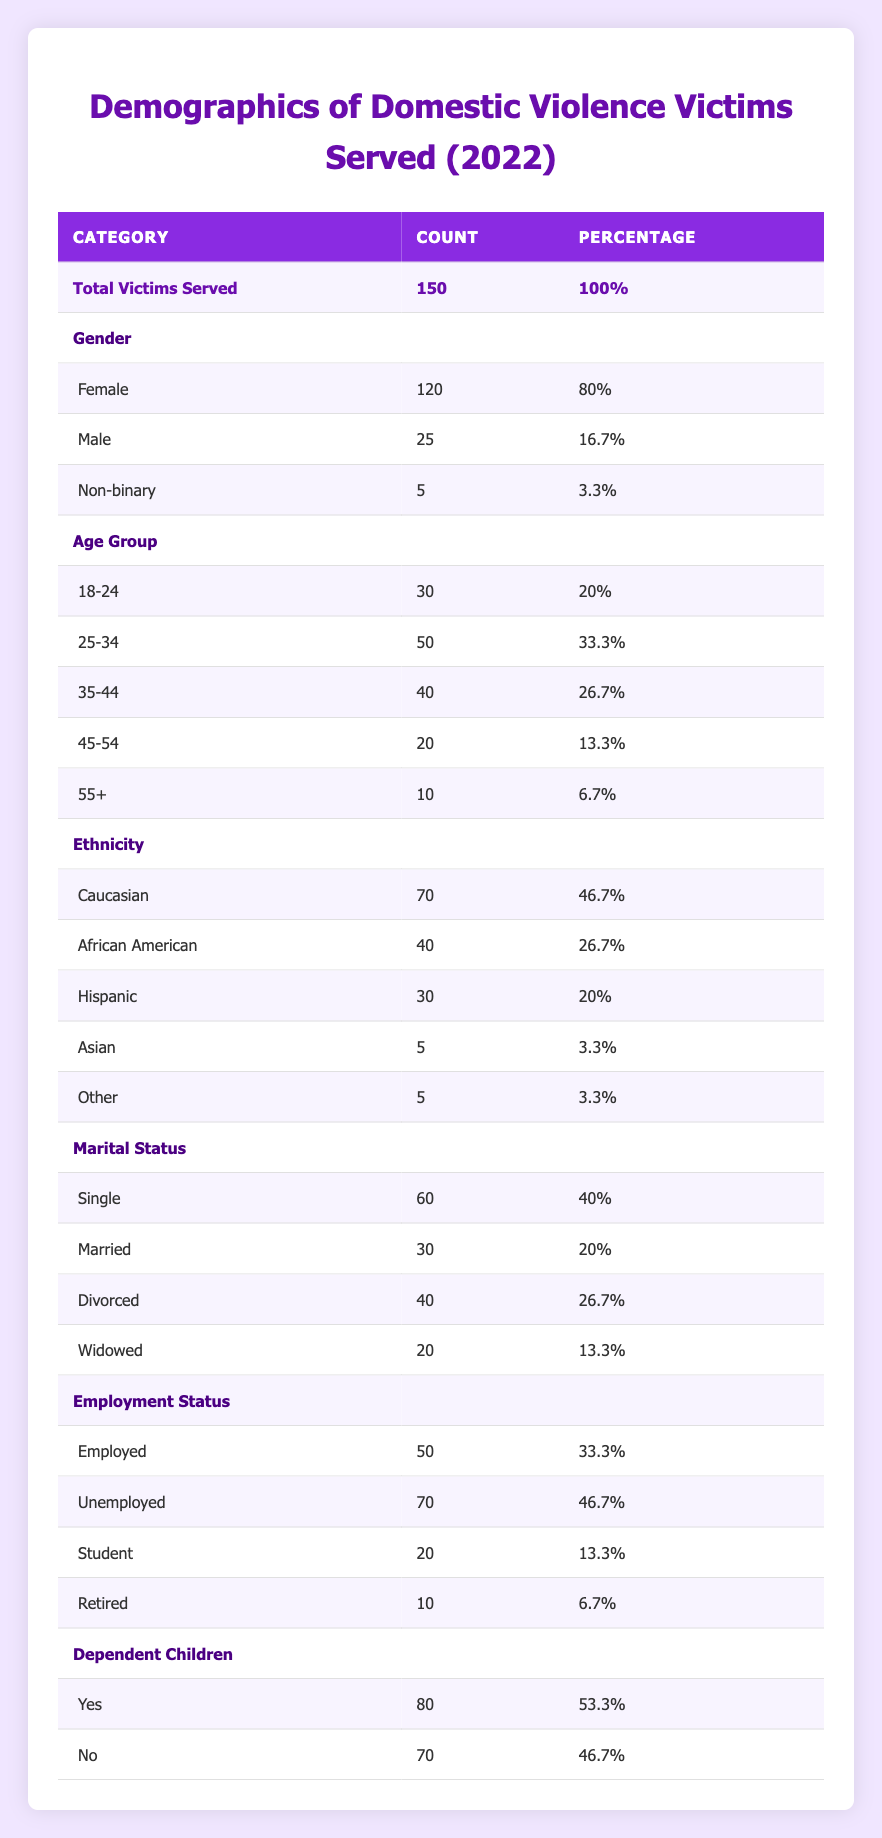What percentage of victims served were female? The table shows that 120 out of 150 total victims served were female. To find the percentage, we calculate (120/150) * 100 = 80%.
Answer: 80% How many victims in the age group 25-34 were served? According to the table, the number of victims in the age group 25-34 is directly listed as 50.
Answer: 50 What is the total number of victims who are unemployed or retired? From the table, the count of unemployed victims is 70 and retired victims is 10. Adding these together gives us 70 + 10 = 80.
Answer: 80 Is the majority of victims served employed? There are 50 employed victims and 70 unemployed victims. Since 70 is greater than 50, the majority are not employed.
Answer: No What is the average number of victims in the age group of 35-44 and the 45-54 age group combined? The number of victims in the age group 35-44 is 40 and in the age group 45-54 is 20. Adding these gives us 40 + 20 = 60. Now to find the average, we divide by the number of groups (2), so 60/2 = 30.
Answer: 30 How many victims were either married or widowed? The table shows that there are 30 married victims and 20 widowed victims. Adding these together gives us 30 + 20 = 50.
Answer: 50 What is the percentage of victims who have dependent children? The table states that 80 victims have dependent children out of a total of 150. The percentage is calculated as (80/150) * 100 = 53.3%.
Answer: 53.3% Are there more Hispanic victims or Asian victims? The counts are 30 for Hispanic victims and 5 for Asian victims. Since 30 is greater than 5, there are more Hispanic victims.
Answer: Yes What is the ratio of single to divorced victims? The number of single victims is 60 and divorced victims is 40. The ratio can be simplified as 60:40, which reduces to 3:2.
Answer: 3:2 